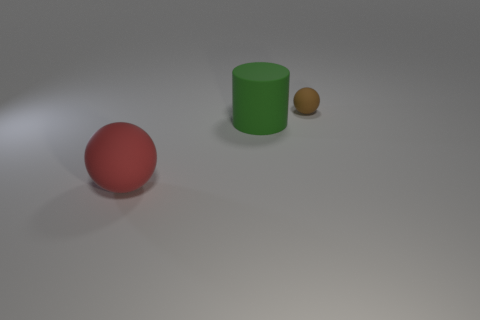What number of other things are there of the same shape as the tiny brown rubber object?
Keep it short and to the point. 1. Is the size of the thing that is on the right side of the green matte cylinder the same as the large green thing?
Provide a short and direct response. No. Is the number of small matte balls that are behind the tiny sphere greater than the number of tiny brown spheres?
Your answer should be very brief. No. What number of brown things are to the right of the sphere that is in front of the small thing?
Give a very brief answer. 1. Are there fewer brown things left of the small brown object than tiny purple rubber things?
Provide a short and direct response. No. Is there a large red object that is behind the matte sphere behind the sphere that is to the left of the green cylinder?
Provide a short and direct response. No. What color is the ball behind the ball left of the rubber cylinder?
Provide a succinct answer. Brown. There is a rubber ball right of the sphere in front of the matte thing that is on the right side of the green matte cylinder; what size is it?
Make the answer very short. Small. Is the shape of the red matte object the same as the object behind the large green thing?
Provide a succinct answer. Yes. What number of other things are there of the same size as the brown rubber sphere?
Provide a short and direct response. 0. 